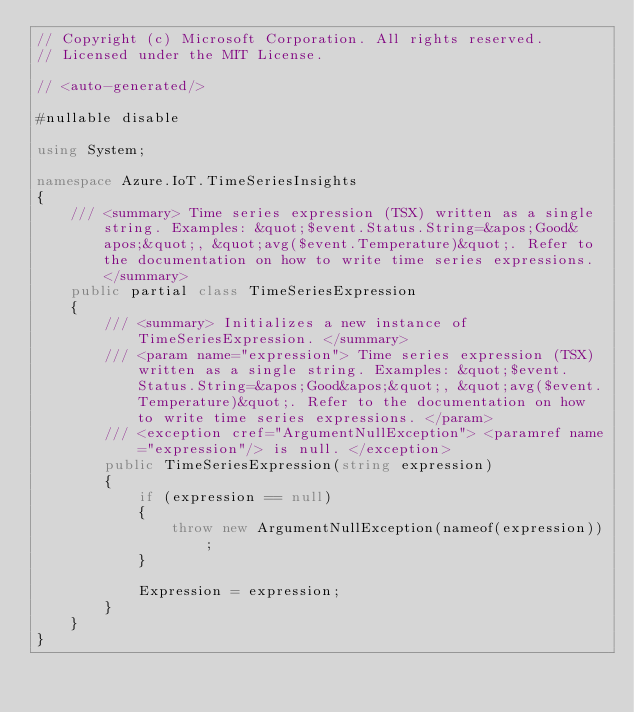Convert code to text. <code><loc_0><loc_0><loc_500><loc_500><_C#_>// Copyright (c) Microsoft Corporation. All rights reserved.
// Licensed under the MIT License.

// <auto-generated/>

#nullable disable

using System;

namespace Azure.IoT.TimeSeriesInsights
{
    /// <summary> Time series expression (TSX) written as a single string. Examples: &quot;$event.Status.String=&apos;Good&apos;&quot;, &quot;avg($event.Temperature)&quot;. Refer to the documentation on how to write time series expressions. </summary>
    public partial class TimeSeriesExpression
    {
        /// <summary> Initializes a new instance of TimeSeriesExpression. </summary>
        /// <param name="expression"> Time series expression (TSX) written as a single string. Examples: &quot;$event.Status.String=&apos;Good&apos;&quot;, &quot;avg($event.Temperature)&quot;. Refer to the documentation on how to write time series expressions. </param>
        /// <exception cref="ArgumentNullException"> <paramref name="expression"/> is null. </exception>
        public TimeSeriesExpression(string expression)
        {
            if (expression == null)
            {
                throw new ArgumentNullException(nameof(expression));
            }

            Expression = expression;
        }
    }
}
</code> 